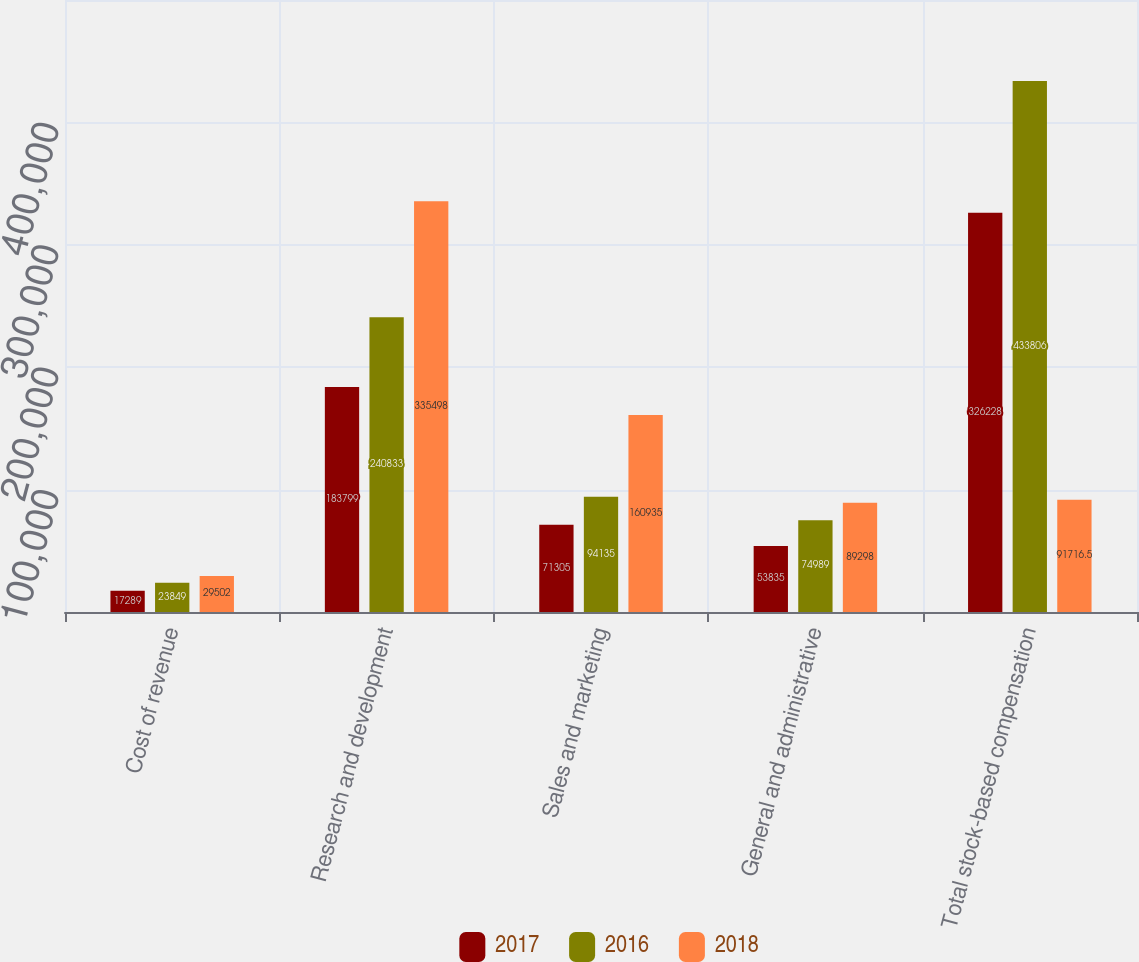<chart> <loc_0><loc_0><loc_500><loc_500><stacked_bar_chart><ecel><fcel>Cost of revenue<fcel>Research and development<fcel>Sales and marketing<fcel>General and administrative<fcel>Total stock-based compensation<nl><fcel>2017<fcel>17289<fcel>183799<fcel>71305<fcel>53835<fcel>326228<nl><fcel>2016<fcel>23849<fcel>240833<fcel>94135<fcel>74989<fcel>433806<nl><fcel>2018<fcel>29502<fcel>335498<fcel>160935<fcel>89298<fcel>91716.5<nl></chart> 